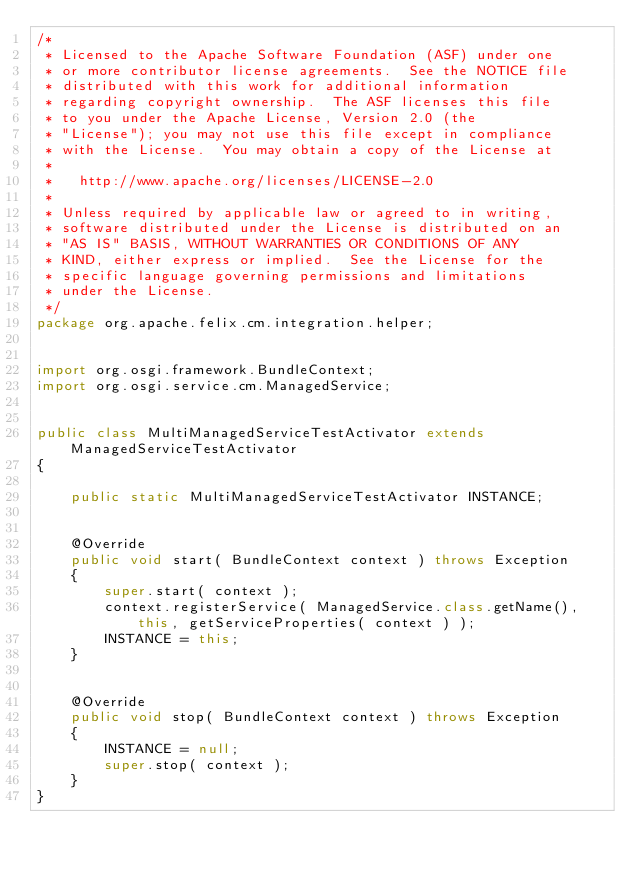<code> <loc_0><loc_0><loc_500><loc_500><_Java_>/*
 * Licensed to the Apache Software Foundation (ASF) under one
 * or more contributor license agreements.  See the NOTICE file
 * distributed with this work for additional information
 * regarding copyright ownership.  The ASF licenses this file
 * to you under the Apache License, Version 2.0 (the
 * "License"); you may not use this file except in compliance
 * with the License.  You may obtain a copy of the License at
 *
 *   http://www.apache.org/licenses/LICENSE-2.0
 *
 * Unless required by applicable law or agreed to in writing,
 * software distributed under the License is distributed on an
 * "AS IS" BASIS, WITHOUT WARRANTIES OR CONDITIONS OF ANY
 * KIND, either express or implied.  See the License for the
 * specific language governing permissions and limitations
 * under the License.
 */
package org.apache.felix.cm.integration.helper;


import org.osgi.framework.BundleContext;
import org.osgi.service.cm.ManagedService;


public class MultiManagedServiceTestActivator extends ManagedServiceTestActivator
{

    public static MultiManagedServiceTestActivator INSTANCE;


    @Override
    public void start( BundleContext context ) throws Exception
    {
        super.start( context );
        context.registerService( ManagedService.class.getName(), this, getServiceProperties( context ) );
        INSTANCE = this;
    }


    @Override
    public void stop( BundleContext context ) throws Exception
    {
        INSTANCE = null;
        super.stop( context );
    }
}
</code> 